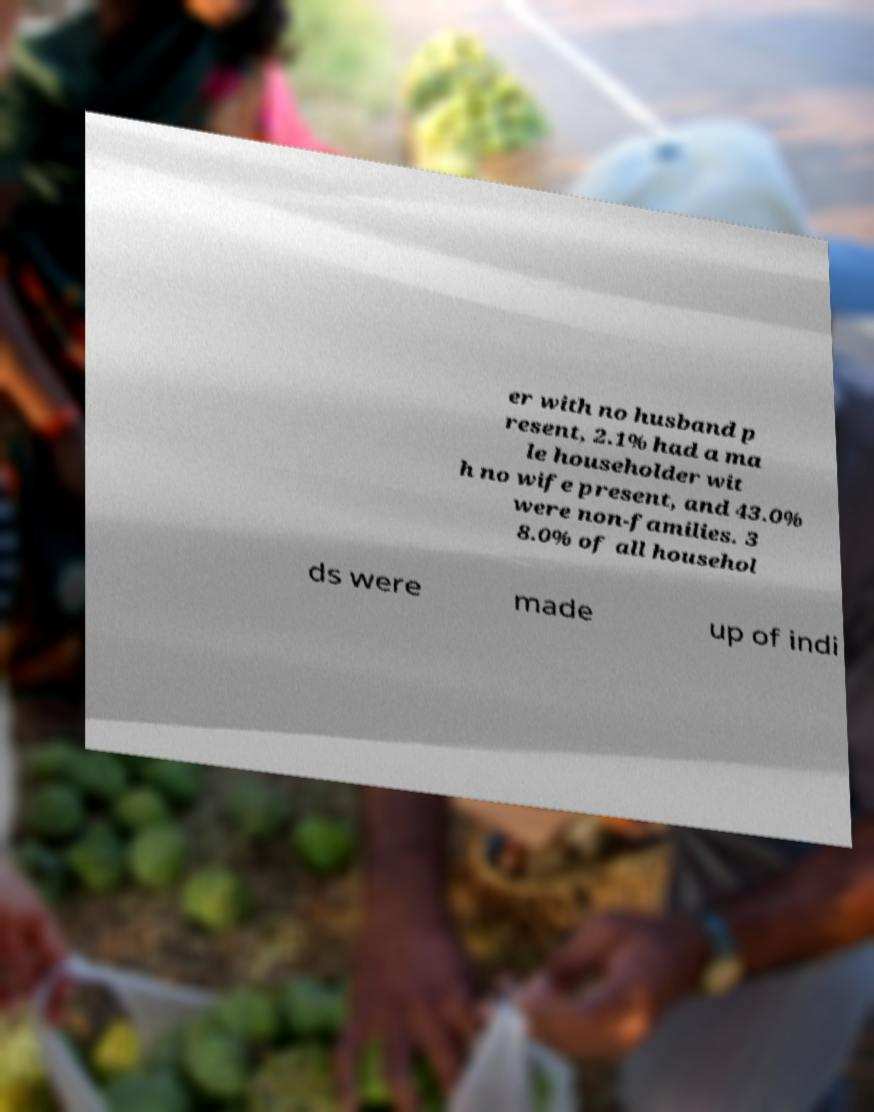Could you assist in decoding the text presented in this image and type it out clearly? er with no husband p resent, 2.1% had a ma le householder wit h no wife present, and 43.0% were non-families. 3 8.0% of all househol ds were made up of indi 